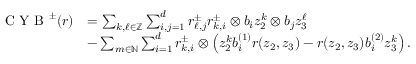Convert formula to latex. <formula><loc_0><loc_0><loc_500><loc_500>\begin{array} { r l } { C Y B ^ { \pm } ( r ) } & { = \sum _ { k , \ell \in \mathbb { Z } } \sum _ { i , j = 1 } ^ { d } r _ { \ell , j } ^ { \pm } r _ { k , i } ^ { \pm } \otimes b _ { i } z _ { 2 } ^ { k } \otimes b _ { j } z _ { 3 } ^ { \ell } } \\ & { - \sum _ { m \in \mathbb { N } } \sum _ { i = 1 } ^ { d } r _ { k , i } ^ { \pm } \otimes \left ( z _ { 2 } ^ { k } b _ { i } ^ { ( 1 ) } r ( z _ { 2 } , z _ { 3 } ) - r ( z _ { 2 } , z _ { 3 } ) b _ { i } ^ { ( 2 ) } z _ { 3 } ^ { k } \right ) . } \end{array}</formula> 